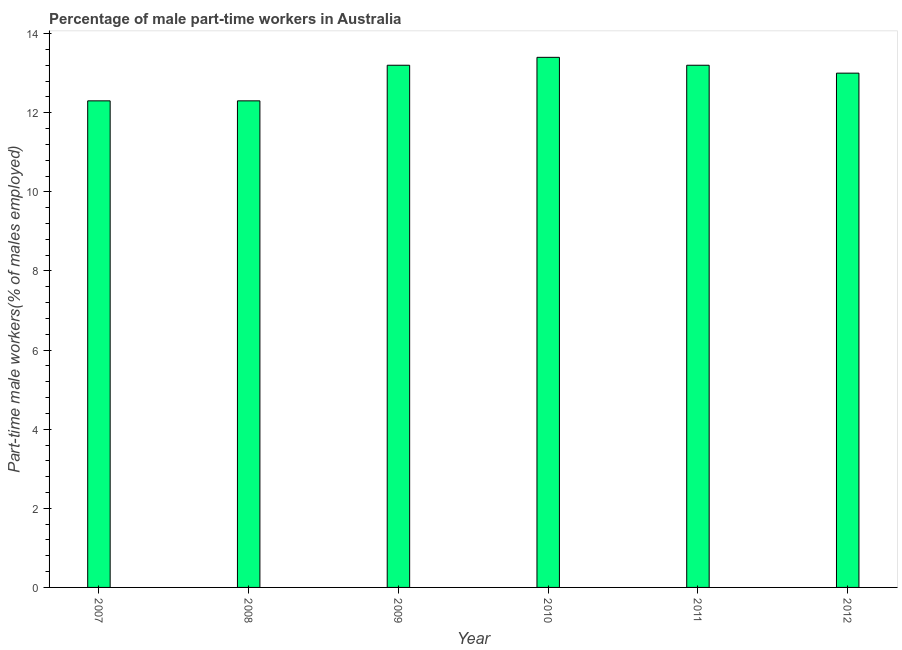What is the title of the graph?
Make the answer very short. Percentage of male part-time workers in Australia. What is the label or title of the X-axis?
Ensure brevity in your answer.  Year. What is the label or title of the Y-axis?
Offer a very short reply. Part-time male workers(% of males employed). What is the percentage of part-time male workers in 2007?
Ensure brevity in your answer.  12.3. Across all years, what is the maximum percentage of part-time male workers?
Provide a short and direct response. 13.4. Across all years, what is the minimum percentage of part-time male workers?
Your answer should be very brief. 12.3. In which year was the percentage of part-time male workers maximum?
Provide a succinct answer. 2010. What is the sum of the percentage of part-time male workers?
Your answer should be very brief. 77.4. What is the median percentage of part-time male workers?
Keep it short and to the point. 13.1. Is the percentage of part-time male workers in 2008 less than that in 2009?
Ensure brevity in your answer.  Yes. Is the difference between the percentage of part-time male workers in 2008 and 2010 greater than the difference between any two years?
Give a very brief answer. Yes. Is the sum of the percentage of part-time male workers in 2008 and 2010 greater than the maximum percentage of part-time male workers across all years?
Offer a very short reply. Yes. What is the difference between the highest and the lowest percentage of part-time male workers?
Your response must be concise. 1.1. In how many years, is the percentage of part-time male workers greater than the average percentage of part-time male workers taken over all years?
Provide a succinct answer. 4. How many years are there in the graph?
Give a very brief answer. 6. What is the difference between two consecutive major ticks on the Y-axis?
Offer a very short reply. 2. What is the Part-time male workers(% of males employed) in 2007?
Offer a very short reply. 12.3. What is the Part-time male workers(% of males employed) in 2008?
Provide a short and direct response. 12.3. What is the Part-time male workers(% of males employed) of 2009?
Offer a terse response. 13.2. What is the Part-time male workers(% of males employed) in 2010?
Offer a very short reply. 13.4. What is the Part-time male workers(% of males employed) of 2011?
Provide a short and direct response. 13.2. What is the Part-time male workers(% of males employed) of 2012?
Keep it short and to the point. 13. What is the difference between the Part-time male workers(% of males employed) in 2007 and 2008?
Provide a short and direct response. 0. What is the difference between the Part-time male workers(% of males employed) in 2007 and 2009?
Give a very brief answer. -0.9. What is the difference between the Part-time male workers(% of males employed) in 2007 and 2010?
Provide a succinct answer. -1.1. What is the difference between the Part-time male workers(% of males employed) in 2007 and 2011?
Your answer should be very brief. -0.9. What is the difference between the Part-time male workers(% of males employed) in 2007 and 2012?
Your response must be concise. -0.7. What is the difference between the Part-time male workers(% of males employed) in 2008 and 2009?
Provide a succinct answer. -0.9. What is the difference between the Part-time male workers(% of males employed) in 2008 and 2011?
Keep it short and to the point. -0.9. What is the difference between the Part-time male workers(% of males employed) in 2008 and 2012?
Provide a short and direct response. -0.7. What is the difference between the Part-time male workers(% of males employed) in 2009 and 2010?
Your answer should be compact. -0.2. What is the difference between the Part-time male workers(% of males employed) in 2009 and 2011?
Make the answer very short. 0. What is the difference between the Part-time male workers(% of males employed) in 2010 and 2011?
Your response must be concise. 0.2. What is the difference between the Part-time male workers(% of males employed) in 2010 and 2012?
Your response must be concise. 0.4. What is the difference between the Part-time male workers(% of males employed) in 2011 and 2012?
Provide a short and direct response. 0.2. What is the ratio of the Part-time male workers(% of males employed) in 2007 to that in 2009?
Your response must be concise. 0.93. What is the ratio of the Part-time male workers(% of males employed) in 2007 to that in 2010?
Offer a very short reply. 0.92. What is the ratio of the Part-time male workers(% of males employed) in 2007 to that in 2011?
Make the answer very short. 0.93. What is the ratio of the Part-time male workers(% of males employed) in 2007 to that in 2012?
Provide a succinct answer. 0.95. What is the ratio of the Part-time male workers(% of males employed) in 2008 to that in 2009?
Offer a very short reply. 0.93. What is the ratio of the Part-time male workers(% of males employed) in 2008 to that in 2010?
Make the answer very short. 0.92. What is the ratio of the Part-time male workers(% of males employed) in 2008 to that in 2011?
Keep it short and to the point. 0.93. What is the ratio of the Part-time male workers(% of males employed) in 2008 to that in 2012?
Make the answer very short. 0.95. What is the ratio of the Part-time male workers(% of males employed) in 2009 to that in 2010?
Ensure brevity in your answer.  0.98. What is the ratio of the Part-time male workers(% of males employed) in 2009 to that in 2011?
Make the answer very short. 1. What is the ratio of the Part-time male workers(% of males employed) in 2010 to that in 2012?
Provide a succinct answer. 1.03. 